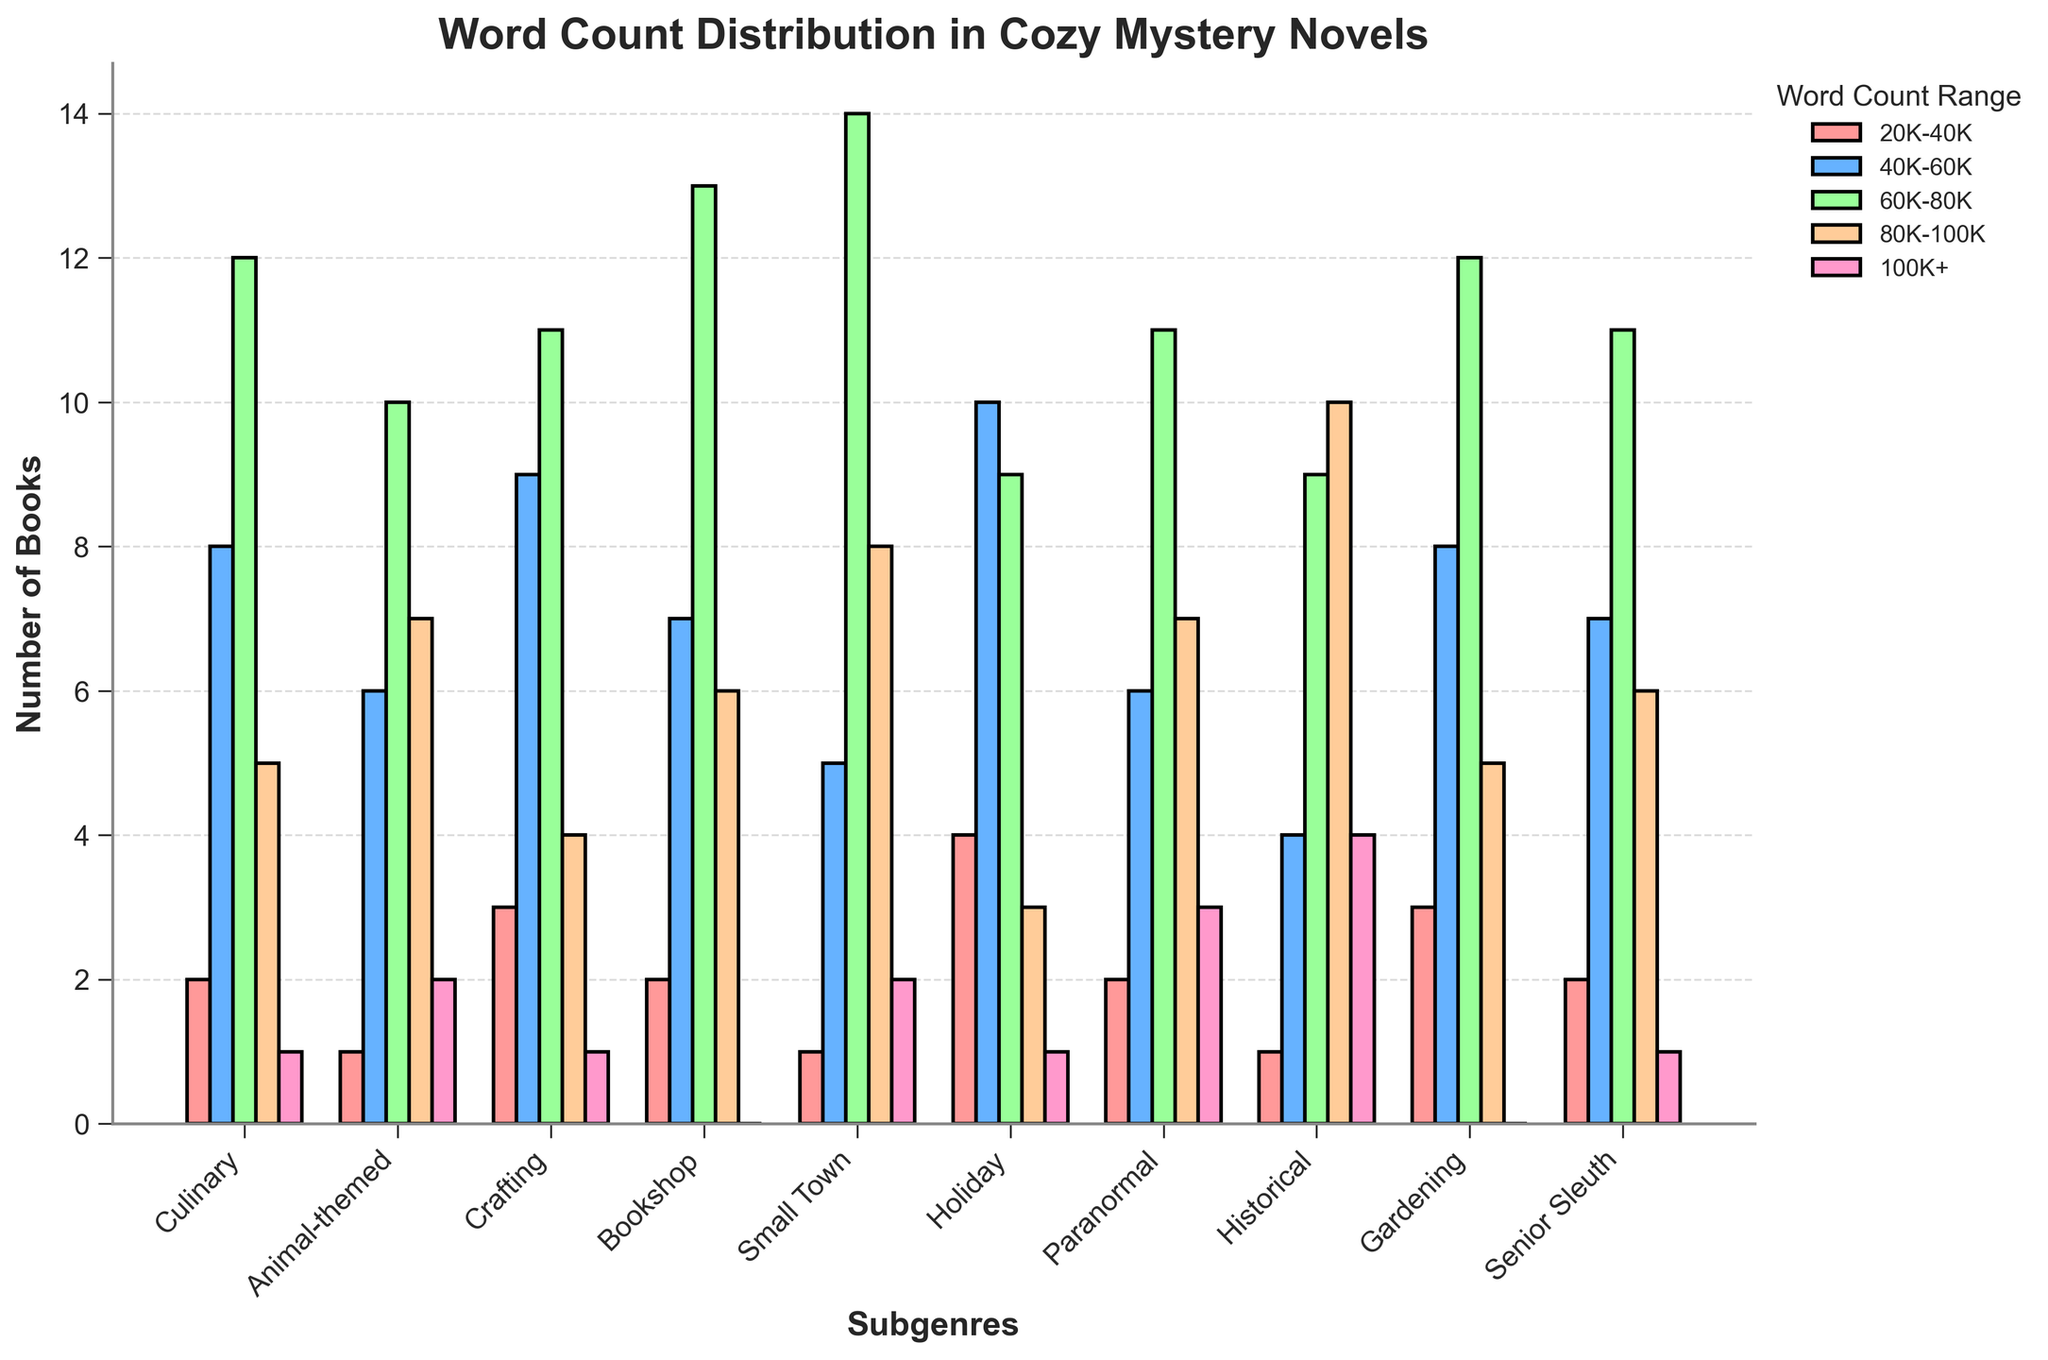What's the title of the figure? The title of a figure is usually displayed at the top. For this figure, it reads "Word Count Distribution in Cozy Mystery Novels".
Answer: Word Count Distribution in Cozy Mystery Novels How many subgenres have novels with word counts over 100,000? By examining the bars under the 100K+ label, we see the quantities in each subgenre. Historical and Paranormal have the highest counts with 4 and 3 books respectively, followed by Small Town, Animal-themed, and Holiday with 2 books each. This gives a total of 5 subgenres.
Answer: 5 Which subgenre has the highest number of books in the 80K-100K word count range? Looking at the tallest bar under the 80K-100K label, the Historical subgenre's bar is the highest, representing 10 books.
Answer: Historical How many more books are there in the Crafting subgenre with a word count of 40K-60K compared to the Senior Sleuth subgenre? The Crafting subgenre has 9 books in the 40K-60K range, while the Senior Sleuth subgenre has 7 books. So, the difference is 9 - 7 = 2 books.
Answer: 2 What's the average number of books in the 40K-60K word count range across all subgenres? Summing up the books in the 40K-60K range for all subgenres: 8 + 6 + 9 + 7 + 5 + 10 + 6 + 4 + 8 + 7 = 70. Dividing by the number of subgenres (10), the average is 70/10 = 7.
Answer: 7 In which range does the Bookshop subgenre have the most books, and how many? Observing the bar heights for the Bookshop subgenre, the tallest bar is in the 60K-80K word count range with 13 books.
Answer: 60K-80K, 13 Compare the word count distribution of the Holiday subgenre with the Gardening subgenre. Which subgenre has more books in the 20K-40K range? The Holiday subgenre has 4 books in the 20K-40K range, while the Gardening subgenre has 3 books. Thus, Holiday has more books in this range.
Answer: Holiday Which word count range is least common across all subgenres, and how many books are there in this range? By summing the counts for each word range: 20K-40K: 21, 40K-60K: 70, 60K-80K: 112, 80K-100K: 61, 100K+: 15. The least common range is 100K+ with 15 books.
Answer: 100K+, 15 